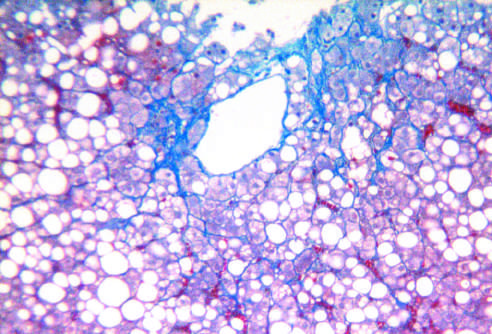what is associated with chronic alcohol use?
Answer the question using a single word or phrase. Fatty liver disease 